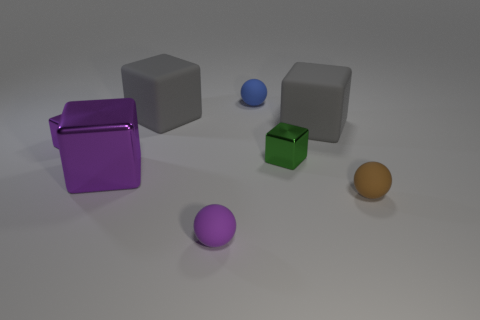Subtract all green metal blocks. How many blocks are left? 4 Subtract all gray balls. How many purple cubes are left? 2 Subtract 1 cubes. How many cubes are left? 4 Subtract all gray cubes. How many cubes are left? 3 Add 2 brown metal spheres. How many objects exist? 10 Subtract 0 red cylinders. How many objects are left? 8 Subtract all balls. How many objects are left? 5 Subtract all gray balls. Subtract all cyan cylinders. How many balls are left? 3 Subtract all small green cubes. Subtract all green metallic objects. How many objects are left? 6 Add 3 small purple blocks. How many small purple blocks are left? 4 